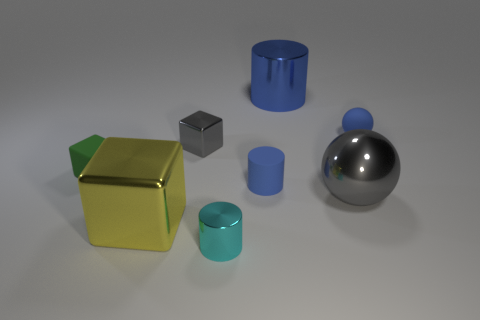Add 2 tiny brown matte balls. How many objects exist? 10 Subtract all cubes. How many objects are left? 5 Add 1 blue matte spheres. How many blue matte spheres are left? 2 Add 5 tiny gray matte things. How many tiny gray matte things exist? 5 Subtract 0 purple cylinders. How many objects are left? 8 Subtract all large yellow things. Subtract all red matte blocks. How many objects are left? 7 